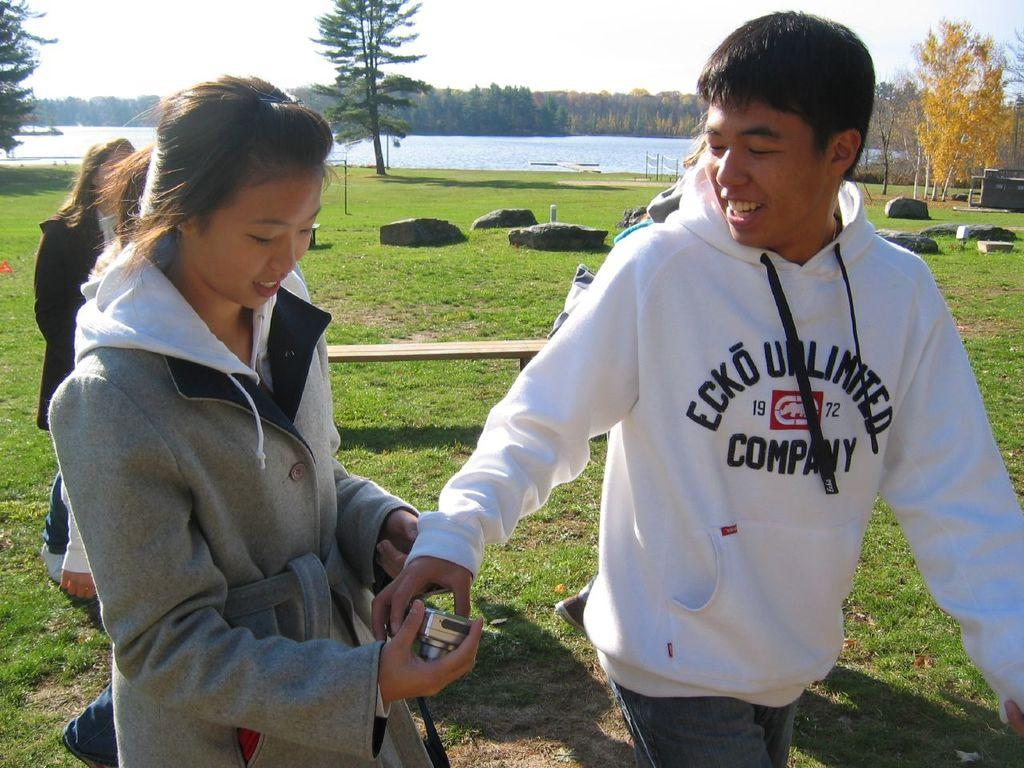<image>
Describe the image concisely. Boy wearing a sweater which says Ecko Unlimited. 